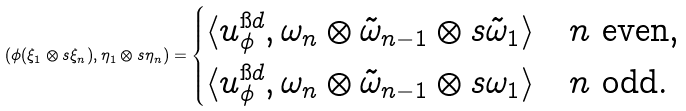Convert formula to latex. <formula><loc_0><loc_0><loc_500><loc_500>( \phi ( \xi _ { 1 } \otimes s \xi _ { n } ) , \eta _ { 1 } \otimes s \eta _ { n } ) = \begin{cases} \langle u ^ { \i d } _ { \phi } , \omega _ { n } \otimes \tilde { \omega } _ { n - 1 } \otimes s \tilde { \omega } _ { 1 } \rangle \quad \text {$n$ even,} \\ \langle u ^ { \i d } _ { \phi } , \omega _ { n } \otimes \tilde { \omega } _ { n - 1 } \otimes s { \omega } _ { 1 } \rangle \quad \text {$n$ odd.} \end{cases}</formula> 